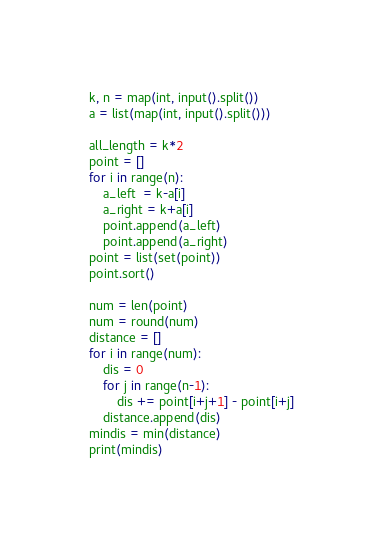Convert code to text. <code><loc_0><loc_0><loc_500><loc_500><_Python_>k, n = map(int, input().split())
a = list(map(int, input().split()))

all_length = k*2
point = []
for i in range(n):
    a_left  = k-a[i]
    a_right = k+a[i]
    point.append(a_left)
    point.append(a_right)
point = list(set(point))
point.sort()

num = len(point)
num = round(num)
distance = []
for i in range(num):
    dis = 0
    for j in range(n-1):
        dis += point[i+j+1] - point[i+j]
    distance.append(dis)
mindis = min(distance)
print(mindis)</code> 